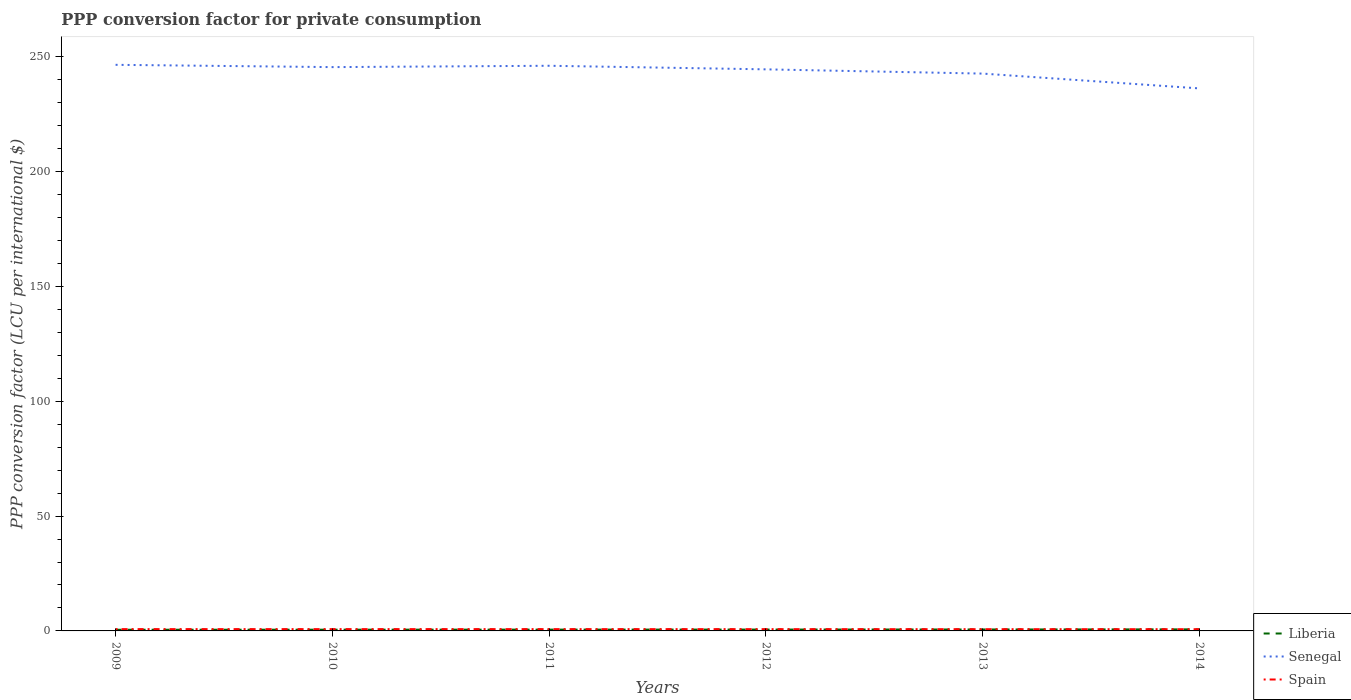How many different coloured lines are there?
Offer a very short reply. 3. Across all years, what is the maximum PPP conversion factor for private consumption in Liberia?
Ensure brevity in your answer.  0.51. What is the total PPP conversion factor for private consumption in Senegal in the graph?
Your answer should be very brief. 8.3. What is the difference between the highest and the second highest PPP conversion factor for private consumption in Senegal?
Your answer should be compact. 10.27. Is the PPP conversion factor for private consumption in Senegal strictly greater than the PPP conversion factor for private consumption in Liberia over the years?
Keep it short and to the point. No. How many years are there in the graph?
Offer a terse response. 6. What is the difference between two consecutive major ticks on the Y-axis?
Offer a very short reply. 50. Does the graph contain any zero values?
Your answer should be very brief. No. How many legend labels are there?
Your answer should be compact. 3. What is the title of the graph?
Your answer should be very brief. PPP conversion factor for private consumption. What is the label or title of the Y-axis?
Your response must be concise. PPP conversion factor (LCU per international $). What is the PPP conversion factor (LCU per international $) in Liberia in 2009?
Provide a succinct answer. 0.51. What is the PPP conversion factor (LCU per international $) of Senegal in 2009?
Offer a very short reply. 246.52. What is the PPP conversion factor (LCU per international $) in Spain in 2009?
Your response must be concise. 0.78. What is the PPP conversion factor (LCU per international $) of Liberia in 2010?
Ensure brevity in your answer.  0.54. What is the PPP conversion factor (LCU per international $) in Senegal in 2010?
Provide a short and direct response. 245.52. What is the PPP conversion factor (LCU per international $) in Spain in 2010?
Ensure brevity in your answer.  0.78. What is the PPP conversion factor (LCU per international $) in Liberia in 2011?
Ensure brevity in your answer.  0.57. What is the PPP conversion factor (LCU per international $) of Senegal in 2011?
Offer a terse response. 246.11. What is the PPP conversion factor (LCU per international $) in Spain in 2011?
Ensure brevity in your answer.  0.78. What is the PPP conversion factor (LCU per international $) in Liberia in 2012?
Your response must be concise. 0.59. What is the PPP conversion factor (LCU per international $) of Senegal in 2012?
Make the answer very short. 244.55. What is the PPP conversion factor (LCU per international $) in Spain in 2012?
Your answer should be very brief. 0.77. What is the PPP conversion factor (LCU per international $) of Liberia in 2013?
Ensure brevity in your answer.  0.63. What is the PPP conversion factor (LCU per international $) of Senegal in 2013?
Make the answer very short. 242.7. What is the PPP conversion factor (LCU per international $) of Spain in 2013?
Provide a succinct answer. 0.76. What is the PPP conversion factor (LCU per international $) of Liberia in 2014?
Offer a very short reply. 0.68. What is the PPP conversion factor (LCU per international $) of Senegal in 2014?
Your response must be concise. 236.25. What is the PPP conversion factor (LCU per international $) in Spain in 2014?
Offer a very short reply. 0.75. Across all years, what is the maximum PPP conversion factor (LCU per international $) in Liberia?
Give a very brief answer. 0.68. Across all years, what is the maximum PPP conversion factor (LCU per international $) of Senegal?
Provide a succinct answer. 246.52. Across all years, what is the maximum PPP conversion factor (LCU per international $) in Spain?
Provide a succinct answer. 0.78. Across all years, what is the minimum PPP conversion factor (LCU per international $) of Liberia?
Your response must be concise. 0.51. Across all years, what is the minimum PPP conversion factor (LCU per international $) in Senegal?
Give a very brief answer. 236.25. Across all years, what is the minimum PPP conversion factor (LCU per international $) of Spain?
Provide a short and direct response. 0.75. What is the total PPP conversion factor (LCU per international $) in Liberia in the graph?
Your answer should be very brief. 3.52. What is the total PPP conversion factor (LCU per international $) of Senegal in the graph?
Give a very brief answer. 1461.64. What is the total PPP conversion factor (LCU per international $) of Spain in the graph?
Offer a very short reply. 4.63. What is the difference between the PPP conversion factor (LCU per international $) in Liberia in 2009 and that in 2010?
Ensure brevity in your answer.  -0.03. What is the difference between the PPP conversion factor (LCU per international $) in Spain in 2009 and that in 2010?
Ensure brevity in your answer.  -0. What is the difference between the PPP conversion factor (LCU per international $) of Liberia in 2009 and that in 2011?
Your answer should be compact. -0.06. What is the difference between the PPP conversion factor (LCU per international $) of Senegal in 2009 and that in 2011?
Give a very brief answer. 0.41. What is the difference between the PPP conversion factor (LCU per international $) of Spain in 2009 and that in 2011?
Your response must be concise. 0. What is the difference between the PPP conversion factor (LCU per international $) of Liberia in 2009 and that in 2012?
Offer a terse response. -0.08. What is the difference between the PPP conversion factor (LCU per international $) of Senegal in 2009 and that in 2012?
Your response must be concise. 1.97. What is the difference between the PPP conversion factor (LCU per international $) in Spain in 2009 and that in 2012?
Ensure brevity in your answer.  0.01. What is the difference between the PPP conversion factor (LCU per international $) of Liberia in 2009 and that in 2013?
Offer a terse response. -0.12. What is the difference between the PPP conversion factor (LCU per international $) of Senegal in 2009 and that in 2013?
Your response must be concise. 3.82. What is the difference between the PPP conversion factor (LCU per international $) of Spain in 2009 and that in 2013?
Give a very brief answer. 0.03. What is the difference between the PPP conversion factor (LCU per international $) of Liberia in 2009 and that in 2014?
Ensure brevity in your answer.  -0.17. What is the difference between the PPP conversion factor (LCU per international $) of Senegal in 2009 and that in 2014?
Offer a terse response. 10.27. What is the difference between the PPP conversion factor (LCU per international $) of Spain in 2009 and that in 2014?
Provide a succinct answer. 0.03. What is the difference between the PPP conversion factor (LCU per international $) in Liberia in 2010 and that in 2011?
Provide a succinct answer. -0.03. What is the difference between the PPP conversion factor (LCU per international $) in Senegal in 2010 and that in 2011?
Offer a very short reply. -0.59. What is the difference between the PPP conversion factor (LCU per international $) in Spain in 2010 and that in 2011?
Offer a terse response. 0. What is the difference between the PPP conversion factor (LCU per international $) in Liberia in 2010 and that in 2012?
Your answer should be compact. -0.05. What is the difference between the PPP conversion factor (LCU per international $) of Senegal in 2010 and that in 2012?
Give a very brief answer. 0.98. What is the difference between the PPP conversion factor (LCU per international $) in Spain in 2010 and that in 2012?
Your answer should be very brief. 0.01. What is the difference between the PPP conversion factor (LCU per international $) in Liberia in 2010 and that in 2013?
Keep it short and to the point. -0.09. What is the difference between the PPP conversion factor (LCU per international $) of Senegal in 2010 and that in 2013?
Your response must be concise. 2.82. What is the difference between the PPP conversion factor (LCU per international $) of Spain in 2010 and that in 2013?
Give a very brief answer. 0.03. What is the difference between the PPP conversion factor (LCU per international $) of Liberia in 2010 and that in 2014?
Ensure brevity in your answer.  -0.14. What is the difference between the PPP conversion factor (LCU per international $) of Senegal in 2010 and that in 2014?
Provide a succinct answer. 9.27. What is the difference between the PPP conversion factor (LCU per international $) of Spain in 2010 and that in 2014?
Offer a very short reply. 0.03. What is the difference between the PPP conversion factor (LCU per international $) of Liberia in 2011 and that in 2012?
Offer a terse response. -0.03. What is the difference between the PPP conversion factor (LCU per international $) in Senegal in 2011 and that in 2012?
Offer a terse response. 1.56. What is the difference between the PPP conversion factor (LCU per international $) in Spain in 2011 and that in 2012?
Keep it short and to the point. 0.01. What is the difference between the PPP conversion factor (LCU per international $) in Liberia in 2011 and that in 2013?
Your answer should be compact. -0.06. What is the difference between the PPP conversion factor (LCU per international $) in Senegal in 2011 and that in 2013?
Provide a succinct answer. 3.41. What is the difference between the PPP conversion factor (LCU per international $) in Spain in 2011 and that in 2013?
Offer a terse response. 0.02. What is the difference between the PPP conversion factor (LCU per international $) of Liberia in 2011 and that in 2014?
Your answer should be very brief. -0.11. What is the difference between the PPP conversion factor (LCU per international $) in Senegal in 2011 and that in 2014?
Your answer should be very brief. 9.86. What is the difference between the PPP conversion factor (LCU per international $) in Spain in 2011 and that in 2014?
Ensure brevity in your answer.  0.03. What is the difference between the PPP conversion factor (LCU per international $) of Liberia in 2012 and that in 2013?
Your answer should be very brief. -0.04. What is the difference between the PPP conversion factor (LCU per international $) in Senegal in 2012 and that in 2013?
Keep it short and to the point. 1.85. What is the difference between the PPP conversion factor (LCU per international $) in Spain in 2012 and that in 2013?
Provide a short and direct response. 0.01. What is the difference between the PPP conversion factor (LCU per international $) of Liberia in 2012 and that in 2014?
Offer a terse response. -0.09. What is the difference between the PPP conversion factor (LCU per international $) in Senegal in 2012 and that in 2014?
Offer a terse response. 8.3. What is the difference between the PPP conversion factor (LCU per international $) of Spain in 2012 and that in 2014?
Make the answer very short. 0.02. What is the difference between the PPP conversion factor (LCU per international $) in Liberia in 2013 and that in 2014?
Provide a succinct answer. -0.05. What is the difference between the PPP conversion factor (LCU per international $) of Senegal in 2013 and that in 2014?
Your answer should be compact. 6.45. What is the difference between the PPP conversion factor (LCU per international $) of Spain in 2013 and that in 2014?
Your response must be concise. 0.01. What is the difference between the PPP conversion factor (LCU per international $) in Liberia in 2009 and the PPP conversion factor (LCU per international $) in Senegal in 2010?
Provide a short and direct response. -245.01. What is the difference between the PPP conversion factor (LCU per international $) of Liberia in 2009 and the PPP conversion factor (LCU per international $) of Spain in 2010?
Provide a succinct answer. -0.27. What is the difference between the PPP conversion factor (LCU per international $) of Senegal in 2009 and the PPP conversion factor (LCU per international $) of Spain in 2010?
Provide a succinct answer. 245.73. What is the difference between the PPP conversion factor (LCU per international $) in Liberia in 2009 and the PPP conversion factor (LCU per international $) in Senegal in 2011?
Provide a short and direct response. -245.6. What is the difference between the PPP conversion factor (LCU per international $) in Liberia in 2009 and the PPP conversion factor (LCU per international $) in Spain in 2011?
Make the answer very short. -0.27. What is the difference between the PPP conversion factor (LCU per international $) of Senegal in 2009 and the PPP conversion factor (LCU per international $) of Spain in 2011?
Provide a short and direct response. 245.74. What is the difference between the PPP conversion factor (LCU per international $) of Liberia in 2009 and the PPP conversion factor (LCU per international $) of Senegal in 2012?
Provide a succinct answer. -244.03. What is the difference between the PPP conversion factor (LCU per international $) of Liberia in 2009 and the PPP conversion factor (LCU per international $) of Spain in 2012?
Your answer should be very brief. -0.26. What is the difference between the PPP conversion factor (LCU per international $) of Senegal in 2009 and the PPP conversion factor (LCU per international $) of Spain in 2012?
Offer a terse response. 245.75. What is the difference between the PPP conversion factor (LCU per international $) of Liberia in 2009 and the PPP conversion factor (LCU per international $) of Senegal in 2013?
Keep it short and to the point. -242.19. What is the difference between the PPP conversion factor (LCU per international $) of Liberia in 2009 and the PPP conversion factor (LCU per international $) of Spain in 2013?
Provide a succinct answer. -0.25. What is the difference between the PPP conversion factor (LCU per international $) in Senegal in 2009 and the PPP conversion factor (LCU per international $) in Spain in 2013?
Provide a short and direct response. 245.76. What is the difference between the PPP conversion factor (LCU per international $) in Liberia in 2009 and the PPP conversion factor (LCU per international $) in Senegal in 2014?
Your answer should be very brief. -235.74. What is the difference between the PPP conversion factor (LCU per international $) of Liberia in 2009 and the PPP conversion factor (LCU per international $) of Spain in 2014?
Your answer should be very brief. -0.24. What is the difference between the PPP conversion factor (LCU per international $) of Senegal in 2009 and the PPP conversion factor (LCU per international $) of Spain in 2014?
Your answer should be compact. 245.77. What is the difference between the PPP conversion factor (LCU per international $) of Liberia in 2010 and the PPP conversion factor (LCU per international $) of Senegal in 2011?
Your response must be concise. -245.57. What is the difference between the PPP conversion factor (LCU per international $) in Liberia in 2010 and the PPP conversion factor (LCU per international $) in Spain in 2011?
Offer a very short reply. -0.24. What is the difference between the PPP conversion factor (LCU per international $) in Senegal in 2010 and the PPP conversion factor (LCU per international $) in Spain in 2011?
Your answer should be compact. 244.74. What is the difference between the PPP conversion factor (LCU per international $) in Liberia in 2010 and the PPP conversion factor (LCU per international $) in Senegal in 2012?
Offer a very short reply. -244.01. What is the difference between the PPP conversion factor (LCU per international $) of Liberia in 2010 and the PPP conversion factor (LCU per international $) of Spain in 2012?
Offer a terse response. -0.23. What is the difference between the PPP conversion factor (LCU per international $) in Senegal in 2010 and the PPP conversion factor (LCU per international $) in Spain in 2012?
Give a very brief answer. 244.75. What is the difference between the PPP conversion factor (LCU per international $) in Liberia in 2010 and the PPP conversion factor (LCU per international $) in Senegal in 2013?
Offer a terse response. -242.16. What is the difference between the PPP conversion factor (LCU per international $) of Liberia in 2010 and the PPP conversion factor (LCU per international $) of Spain in 2013?
Provide a short and direct response. -0.22. What is the difference between the PPP conversion factor (LCU per international $) in Senegal in 2010 and the PPP conversion factor (LCU per international $) in Spain in 2013?
Provide a succinct answer. 244.76. What is the difference between the PPP conversion factor (LCU per international $) in Liberia in 2010 and the PPP conversion factor (LCU per international $) in Senegal in 2014?
Your answer should be compact. -235.71. What is the difference between the PPP conversion factor (LCU per international $) in Liberia in 2010 and the PPP conversion factor (LCU per international $) in Spain in 2014?
Keep it short and to the point. -0.21. What is the difference between the PPP conversion factor (LCU per international $) in Senegal in 2010 and the PPP conversion factor (LCU per international $) in Spain in 2014?
Give a very brief answer. 244.77. What is the difference between the PPP conversion factor (LCU per international $) in Liberia in 2011 and the PPP conversion factor (LCU per international $) in Senegal in 2012?
Ensure brevity in your answer.  -243.98. What is the difference between the PPP conversion factor (LCU per international $) in Liberia in 2011 and the PPP conversion factor (LCU per international $) in Spain in 2012?
Provide a short and direct response. -0.2. What is the difference between the PPP conversion factor (LCU per international $) of Senegal in 2011 and the PPP conversion factor (LCU per international $) of Spain in 2012?
Offer a terse response. 245.34. What is the difference between the PPP conversion factor (LCU per international $) of Liberia in 2011 and the PPP conversion factor (LCU per international $) of Senegal in 2013?
Ensure brevity in your answer.  -242.13. What is the difference between the PPP conversion factor (LCU per international $) in Liberia in 2011 and the PPP conversion factor (LCU per international $) in Spain in 2013?
Your response must be concise. -0.19. What is the difference between the PPP conversion factor (LCU per international $) of Senegal in 2011 and the PPP conversion factor (LCU per international $) of Spain in 2013?
Your response must be concise. 245.35. What is the difference between the PPP conversion factor (LCU per international $) in Liberia in 2011 and the PPP conversion factor (LCU per international $) in Senegal in 2014?
Provide a succinct answer. -235.68. What is the difference between the PPP conversion factor (LCU per international $) in Liberia in 2011 and the PPP conversion factor (LCU per international $) in Spain in 2014?
Your answer should be compact. -0.18. What is the difference between the PPP conversion factor (LCU per international $) of Senegal in 2011 and the PPP conversion factor (LCU per international $) of Spain in 2014?
Give a very brief answer. 245.36. What is the difference between the PPP conversion factor (LCU per international $) of Liberia in 2012 and the PPP conversion factor (LCU per international $) of Senegal in 2013?
Your response must be concise. -242.1. What is the difference between the PPP conversion factor (LCU per international $) in Liberia in 2012 and the PPP conversion factor (LCU per international $) in Spain in 2013?
Provide a short and direct response. -0.16. What is the difference between the PPP conversion factor (LCU per international $) of Senegal in 2012 and the PPP conversion factor (LCU per international $) of Spain in 2013?
Provide a succinct answer. 243.79. What is the difference between the PPP conversion factor (LCU per international $) in Liberia in 2012 and the PPP conversion factor (LCU per international $) in Senegal in 2014?
Provide a succinct answer. -235.66. What is the difference between the PPP conversion factor (LCU per international $) of Liberia in 2012 and the PPP conversion factor (LCU per international $) of Spain in 2014?
Give a very brief answer. -0.16. What is the difference between the PPP conversion factor (LCU per international $) in Senegal in 2012 and the PPP conversion factor (LCU per international $) in Spain in 2014?
Keep it short and to the point. 243.79. What is the difference between the PPP conversion factor (LCU per international $) of Liberia in 2013 and the PPP conversion factor (LCU per international $) of Senegal in 2014?
Offer a terse response. -235.62. What is the difference between the PPP conversion factor (LCU per international $) in Liberia in 2013 and the PPP conversion factor (LCU per international $) in Spain in 2014?
Provide a succinct answer. -0.12. What is the difference between the PPP conversion factor (LCU per international $) of Senegal in 2013 and the PPP conversion factor (LCU per international $) of Spain in 2014?
Ensure brevity in your answer.  241.95. What is the average PPP conversion factor (LCU per international $) in Liberia per year?
Give a very brief answer. 0.59. What is the average PPP conversion factor (LCU per international $) of Senegal per year?
Keep it short and to the point. 243.61. What is the average PPP conversion factor (LCU per international $) in Spain per year?
Provide a succinct answer. 0.77. In the year 2009, what is the difference between the PPP conversion factor (LCU per international $) of Liberia and PPP conversion factor (LCU per international $) of Senegal?
Provide a succinct answer. -246.01. In the year 2009, what is the difference between the PPP conversion factor (LCU per international $) in Liberia and PPP conversion factor (LCU per international $) in Spain?
Make the answer very short. -0.27. In the year 2009, what is the difference between the PPP conversion factor (LCU per international $) of Senegal and PPP conversion factor (LCU per international $) of Spain?
Offer a very short reply. 245.74. In the year 2010, what is the difference between the PPP conversion factor (LCU per international $) in Liberia and PPP conversion factor (LCU per international $) in Senegal?
Keep it short and to the point. -244.98. In the year 2010, what is the difference between the PPP conversion factor (LCU per international $) of Liberia and PPP conversion factor (LCU per international $) of Spain?
Your answer should be very brief. -0.24. In the year 2010, what is the difference between the PPP conversion factor (LCU per international $) of Senegal and PPP conversion factor (LCU per international $) of Spain?
Give a very brief answer. 244.74. In the year 2011, what is the difference between the PPP conversion factor (LCU per international $) of Liberia and PPP conversion factor (LCU per international $) of Senegal?
Keep it short and to the point. -245.54. In the year 2011, what is the difference between the PPP conversion factor (LCU per international $) of Liberia and PPP conversion factor (LCU per international $) of Spain?
Your answer should be compact. -0.21. In the year 2011, what is the difference between the PPP conversion factor (LCU per international $) in Senegal and PPP conversion factor (LCU per international $) in Spain?
Give a very brief answer. 245.33. In the year 2012, what is the difference between the PPP conversion factor (LCU per international $) of Liberia and PPP conversion factor (LCU per international $) of Senegal?
Ensure brevity in your answer.  -243.95. In the year 2012, what is the difference between the PPP conversion factor (LCU per international $) in Liberia and PPP conversion factor (LCU per international $) in Spain?
Your answer should be very brief. -0.18. In the year 2012, what is the difference between the PPP conversion factor (LCU per international $) in Senegal and PPP conversion factor (LCU per international $) in Spain?
Your answer should be compact. 243.77. In the year 2013, what is the difference between the PPP conversion factor (LCU per international $) in Liberia and PPP conversion factor (LCU per international $) in Senegal?
Give a very brief answer. -242.07. In the year 2013, what is the difference between the PPP conversion factor (LCU per international $) of Liberia and PPP conversion factor (LCU per international $) of Spain?
Provide a short and direct response. -0.13. In the year 2013, what is the difference between the PPP conversion factor (LCU per international $) in Senegal and PPP conversion factor (LCU per international $) in Spain?
Offer a very short reply. 241.94. In the year 2014, what is the difference between the PPP conversion factor (LCU per international $) in Liberia and PPP conversion factor (LCU per international $) in Senegal?
Your answer should be very brief. -235.57. In the year 2014, what is the difference between the PPP conversion factor (LCU per international $) of Liberia and PPP conversion factor (LCU per international $) of Spain?
Provide a succinct answer. -0.07. In the year 2014, what is the difference between the PPP conversion factor (LCU per international $) of Senegal and PPP conversion factor (LCU per international $) of Spain?
Offer a terse response. 235.5. What is the ratio of the PPP conversion factor (LCU per international $) of Liberia in 2009 to that in 2010?
Keep it short and to the point. 0.95. What is the ratio of the PPP conversion factor (LCU per international $) of Liberia in 2009 to that in 2011?
Keep it short and to the point. 0.9. What is the ratio of the PPP conversion factor (LCU per international $) of Spain in 2009 to that in 2011?
Provide a succinct answer. 1. What is the ratio of the PPP conversion factor (LCU per international $) of Liberia in 2009 to that in 2012?
Offer a terse response. 0.86. What is the ratio of the PPP conversion factor (LCU per international $) in Senegal in 2009 to that in 2012?
Give a very brief answer. 1.01. What is the ratio of the PPP conversion factor (LCU per international $) in Spain in 2009 to that in 2012?
Ensure brevity in your answer.  1.02. What is the ratio of the PPP conversion factor (LCU per international $) of Liberia in 2009 to that in 2013?
Make the answer very short. 0.81. What is the ratio of the PPP conversion factor (LCU per international $) in Senegal in 2009 to that in 2013?
Your answer should be compact. 1.02. What is the ratio of the PPP conversion factor (LCU per international $) in Spain in 2009 to that in 2013?
Provide a short and direct response. 1.03. What is the ratio of the PPP conversion factor (LCU per international $) of Liberia in 2009 to that in 2014?
Offer a very short reply. 0.75. What is the ratio of the PPP conversion factor (LCU per international $) of Senegal in 2009 to that in 2014?
Offer a terse response. 1.04. What is the ratio of the PPP conversion factor (LCU per international $) of Spain in 2009 to that in 2014?
Provide a succinct answer. 1.04. What is the ratio of the PPP conversion factor (LCU per international $) in Liberia in 2010 to that in 2011?
Ensure brevity in your answer.  0.95. What is the ratio of the PPP conversion factor (LCU per international $) of Spain in 2010 to that in 2011?
Provide a succinct answer. 1.01. What is the ratio of the PPP conversion factor (LCU per international $) of Liberia in 2010 to that in 2012?
Offer a very short reply. 0.91. What is the ratio of the PPP conversion factor (LCU per international $) in Senegal in 2010 to that in 2012?
Make the answer very short. 1. What is the ratio of the PPP conversion factor (LCU per international $) in Spain in 2010 to that in 2012?
Give a very brief answer. 1.02. What is the ratio of the PPP conversion factor (LCU per international $) of Liberia in 2010 to that in 2013?
Your response must be concise. 0.86. What is the ratio of the PPP conversion factor (LCU per international $) of Senegal in 2010 to that in 2013?
Provide a succinct answer. 1.01. What is the ratio of the PPP conversion factor (LCU per international $) of Spain in 2010 to that in 2013?
Make the answer very short. 1.03. What is the ratio of the PPP conversion factor (LCU per international $) in Liberia in 2010 to that in 2014?
Give a very brief answer. 0.79. What is the ratio of the PPP conversion factor (LCU per international $) of Senegal in 2010 to that in 2014?
Provide a succinct answer. 1.04. What is the ratio of the PPP conversion factor (LCU per international $) in Spain in 2010 to that in 2014?
Your answer should be very brief. 1.04. What is the ratio of the PPP conversion factor (LCU per international $) in Liberia in 2011 to that in 2012?
Your answer should be very brief. 0.96. What is the ratio of the PPP conversion factor (LCU per international $) of Senegal in 2011 to that in 2012?
Give a very brief answer. 1.01. What is the ratio of the PPP conversion factor (LCU per international $) in Spain in 2011 to that in 2012?
Your response must be concise. 1.01. What is the ratio of the PPP conversion factor (LCU per international $) in Liberia in 2011 to that in 2013?
Your answer should be very brief. 0.9. What is the ratio of the PPP conversion factor (LCU per international $) of Spain in 2011 to that in 2013?
Your response must be concise. 1.03. What is the ratio of the PPP conversion factor (LCU per international $) in Liberia in 2011 to that in 2014?
Your response must be concise. 0.83. What is the ratio of the PPP conversion factor (LCU per international $) in Senegal in 2011 to that in 2014?
Your answer should be compact. 1.04. What is the ratio of the PPP conversion factor (LCU per international $) in Spain in 2011 to that in 2014?
Your answer should be compact. 1.04. What is the ratio of the PPP conversion factor (LCU per international $) in Liberia in 2012 to that in 2013?
Your answer should be very brief. 0.94. What is the ratio of the PPP conversion factor (LCU per international $) in Senegal in 2012 to that in 2013?
Provide a short and direct response. 1.01. What is the ratio of the PPP conversion factor (LCU per international $) of Spain in 2012 to that in 2013?
Give a very brief answer. 1.02. What is the ratio of the PPP conversion factor (LCU per international $) in Liberia in 2012 to that in 2014?
Your answer should be very brief. 0.87. What is the ratio of the PPP conversion factor (LCU per international $) in Senegal in 2012 to that in 2014?
Make the answer very short. 1.04. What is the ratio of the PPP conversion factor (LCU per international $) in Spain in 2012 to that in 2014?
Offer a very short reply. 1.03. What is the ratio of the PPP conversion factor (LCU per international $) of Liberia in 2013 to that in 2014?
Your answer should be very brief. 0.93. What is the ratio of the PPP conversion factor (LCU per international $) of Senegal in 2013 to that in 2014?
Your response must be concise. 1.03. What is the ratio of the PPP conversion factor (LCU per international $) in Spain in 2013 to that in 2014?
Give a very brief answer. 1.01. What is the difference between the highest and the second highest PPP conversion factor (LCU per international $) of Liberia?
Provide a succinct answer. 0.05. What is the difference between the highest and the second highest PPP conversion factor (LCU per international $) in Senegal?
Make the answer very short. 0.41. What is the difference between the highest and the second highest PPP conversion factor (LCU per international $) of Spain?
Your answer should be very brief. 0. What is the difference between the highest and the lowest PPP conversion factor (LCU per international $) in Liberia?
Provide a short and direct response. 0.17. What is the difference between the highest and the lowest PPP conversion factor (LCU per international $) of Senegal?
Give a very brief answer. 10.27. What is the difference between the highest and the lowest PPP conversion factor (LCU per international $) in Spain?
Keep it short and to the point. 0.03. 